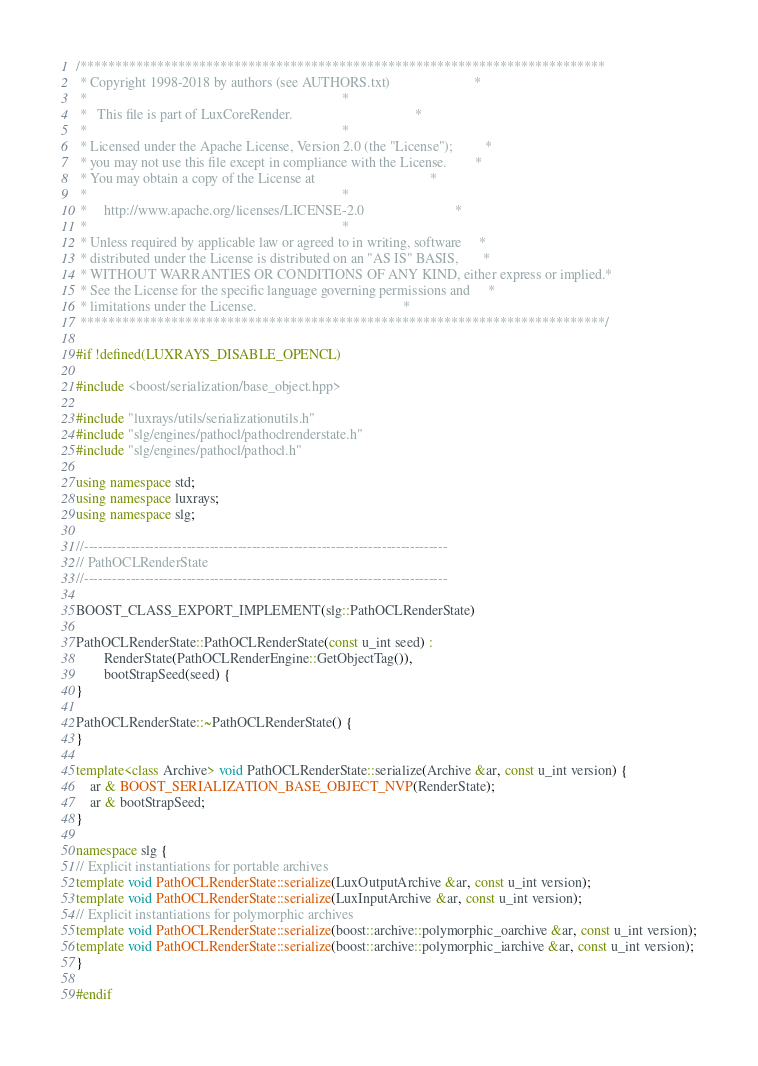<code> <loc_0><loc_0><loc_500><loc_500><_C++_>/***************************************************************************
 * Copyright 1998-2018 by authors (see AUTHORS.txt)                        *
 *                                                                         *
 *   This file is part of LuxCoreRender.                                   *
 *                                                                         *
 * Licensed under the Apache License, Version 2.0 (the "License");         *
 * you may not use this file except in compliance with the License.        *
 * You may obtain a copy of the License at                                 *
 *                                                                         *
 *     http://www.apache.org/licenses/LICENSE-2.0                          *
 *                                                                         *
 * Unless required by applicable law or agreed to in writing, software     *
 * distributed under the License is distributed on an "AS IS" BASIS,       *
 * WITHOUT WARRANTIES OR CONDITIONS OF ANY KIND, either express or implied.*
 * See the License for the specific language governing permissions and     *
 * limitations under the License.                                          *
 ***************************************************************************/

#if !defined(LUXRAYS_DISABLE_OPENCL)

#include <boost/serialization/base_object.hpp>

#include "luxrays/utils/serializationutils.h"
#include "slg/engines/pathocl/pathoclrenderstate.h"
#include "slg/engines/pathocl/pathocl.h"

using namespace std;
using namespace luxrays;
using namespace slg;

//------------------------------------------------------------------------------
// PathOCLRenderState
//------------------------------------------------------------------------------

BOOST_CLASS_EXPORT_IMPLEMENT(slg::PathOCLRenderState)

PathOCLRenderState::PathOCLRenderState(const u_int seed) :
		RenderState(PathOCLRenderEngine::GetObjectTag()),
		bootStrapSeed(seed) {
}

PathOCLRenderState::~PathOCLRenderState() {
}

template<class Archive> void PathOCLRenderState::serialize(Archive &ar, const u_int version) {
	ar & BOOST_SERIALIZATION_BASE_OBJECT_NVP(RenderState);
	ar & bootStrapSeed;
}

namespace slg {
// Explicit instantiations for portable archives
template void PathOCLRenderState::serialize(LuxOutputArchive &ar, const u_int version);
template void PathOCLRenderState::serialize(LuxInputArchive &ar, const u_int version);
// Explicit instantiations for polymorphic archives
template void PathOCLRenderState::serialize(boost::archive::polymorphic_oarchive &ar, const u_int version);
template void PathOCLRenderState::serialize(boost::archive::polymorphic_iarchive &ar, const u_int version);
}

#endif
</code> 